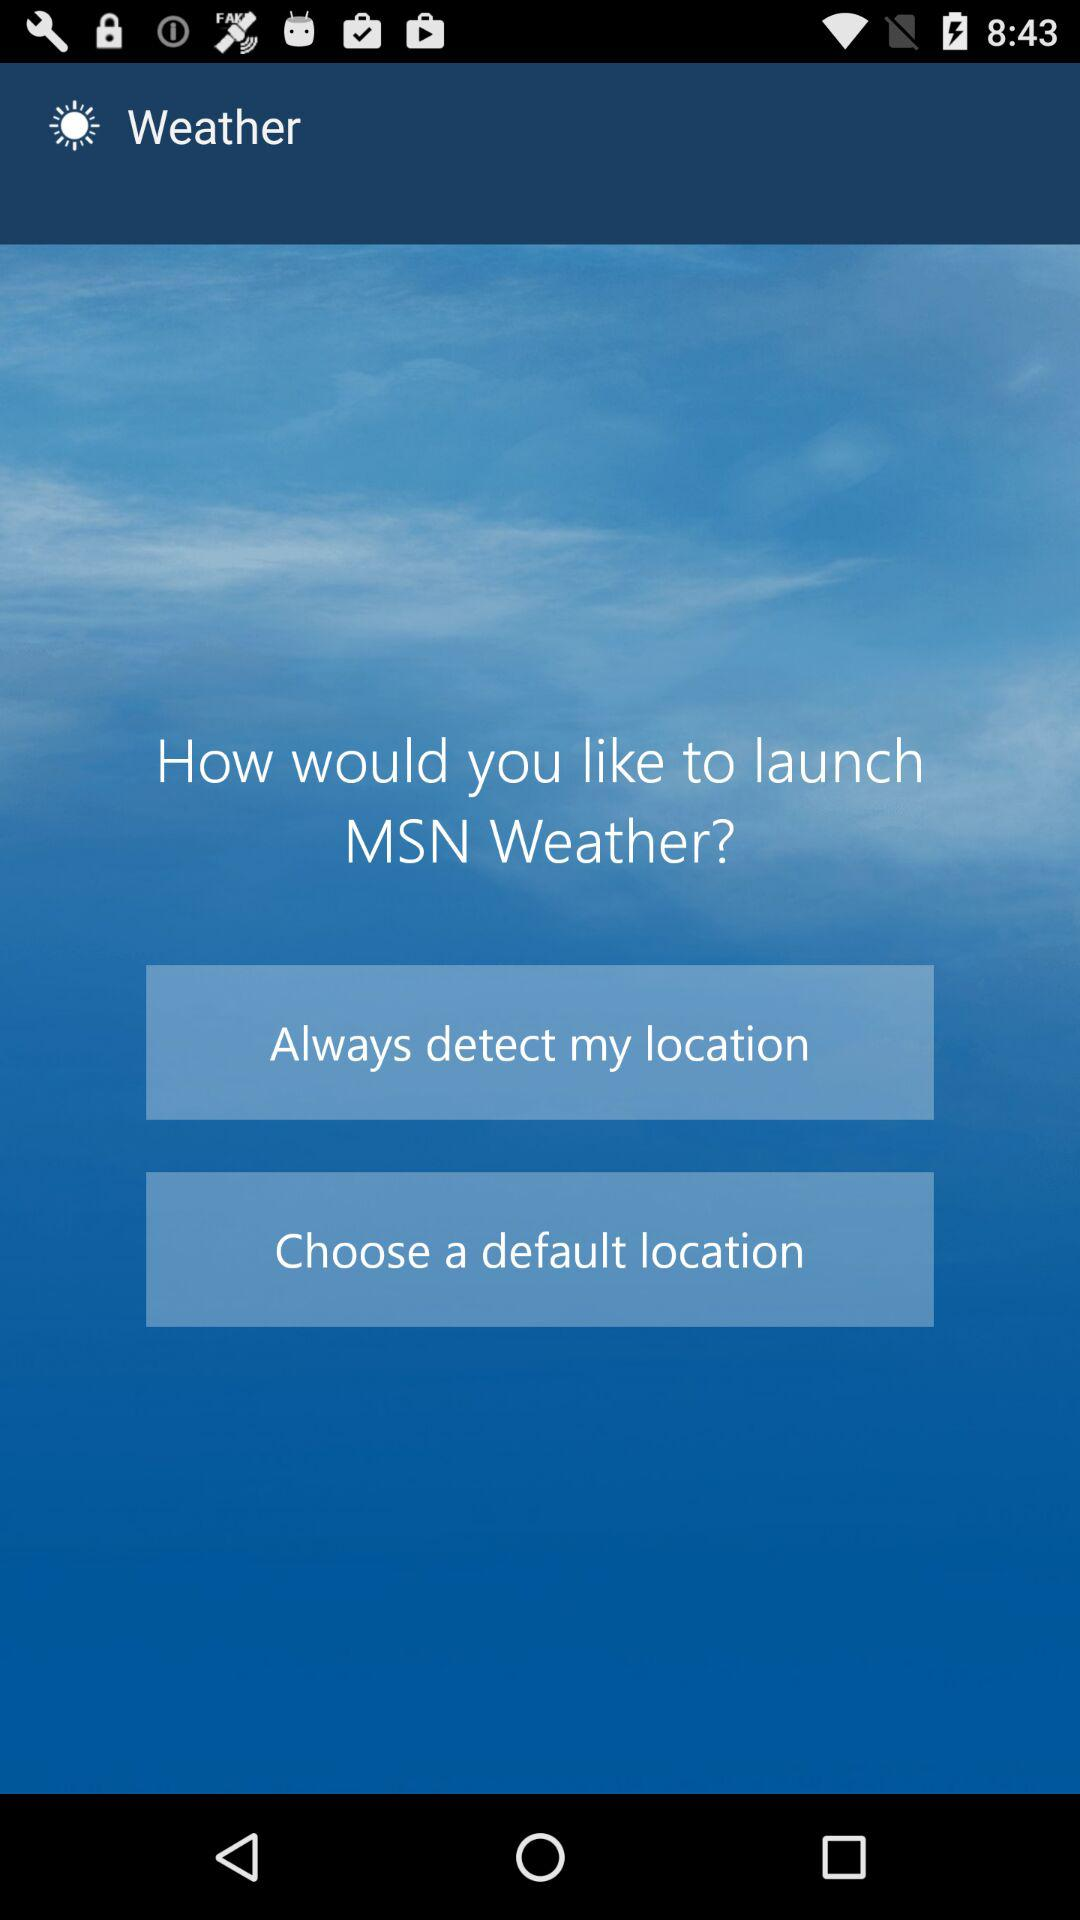Which options are given to select for launching "MSN Weather"? The given options are "Always detect my location" and "Choose a default location". 